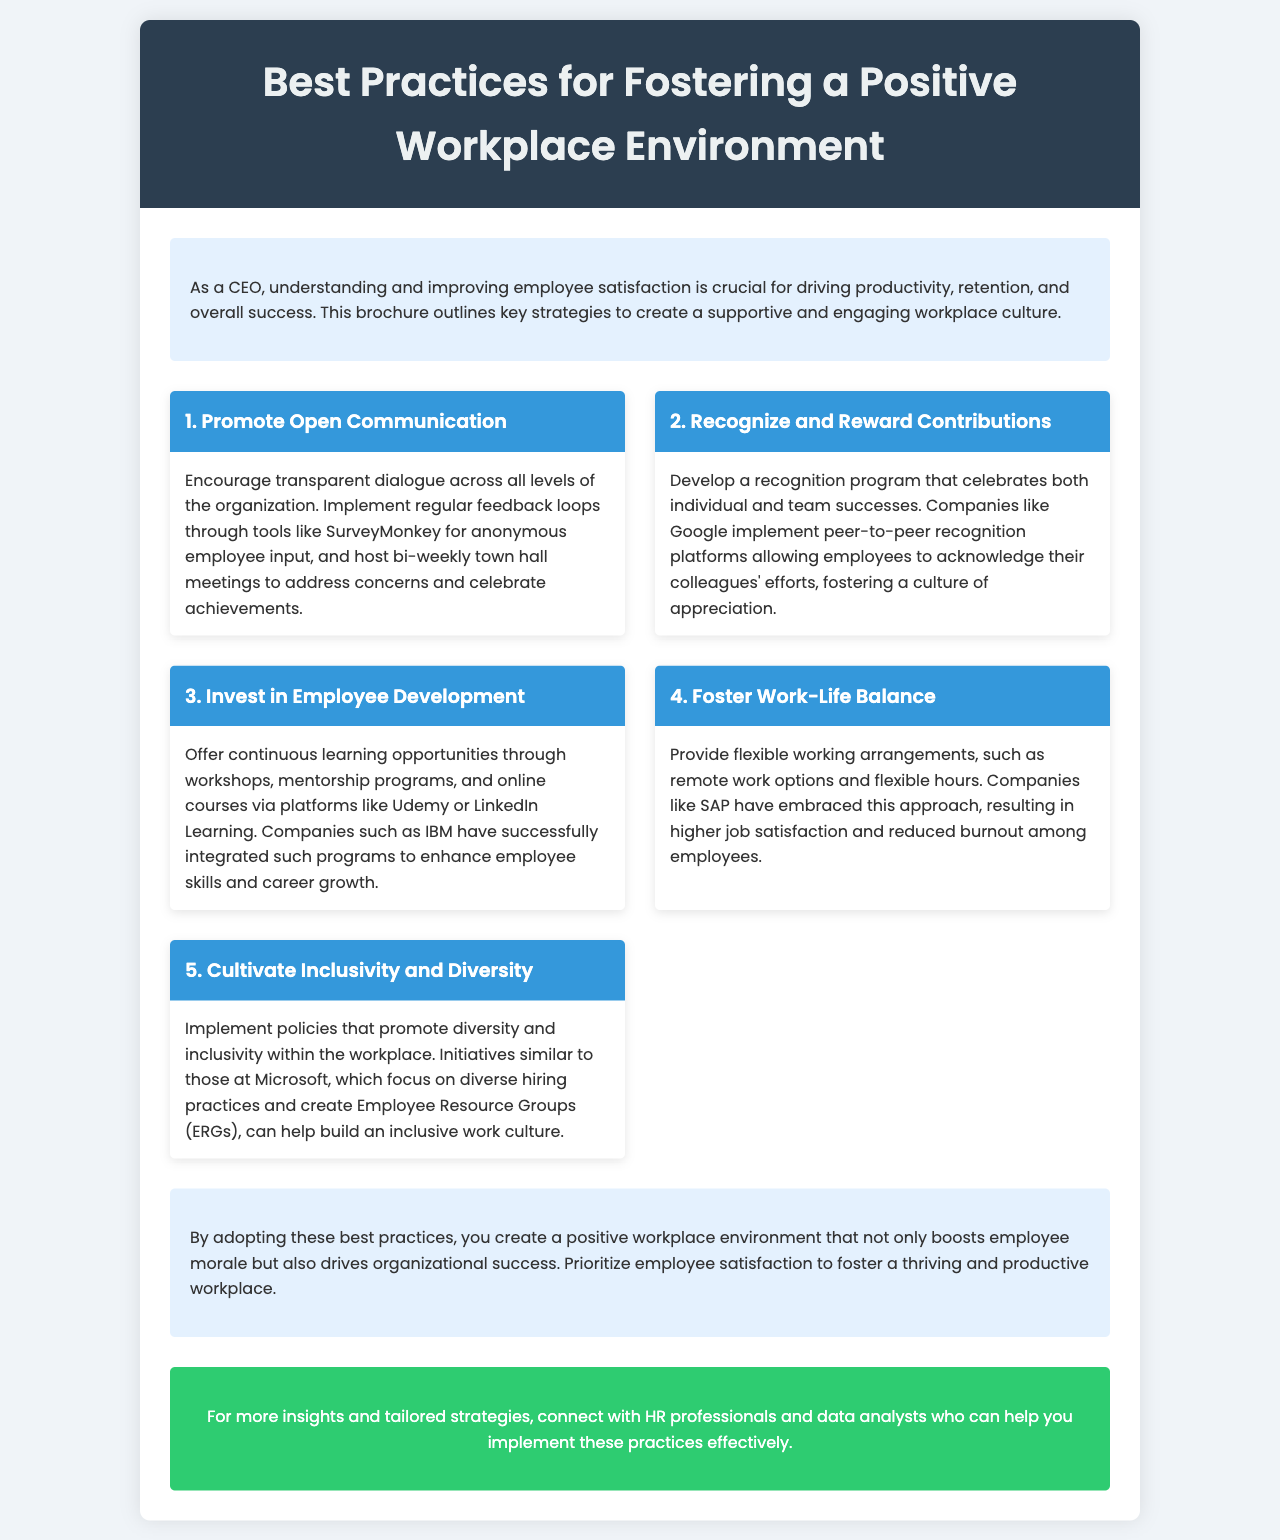What is the title of the brochure? The title is prominently displayed in the header of the document, which is "Best Practices for Fostering a Positive Workplace Environment."
Answer: Best Practices for Fostering a Positive Workplace Environment How many key practices are outlined in the brochure? The brochure lists a total of five key practices to foster a positive workplace environment.
Answer: 5 Which company is mentioned as having implemented a peer-to-peer recognition platform? The document refers to Google as a company that has an effective recognition program for employees.
Answer: Google What is the first key practice listed in the document? The first key practice is displayed as "Promote Open Communication" within the key practices section.
Answer: Promote Open Communication What does the brochure suggest regarding employee development? The brochure recommends providing continuous learning opportunities through various platforms for employee development.
Answer: Continuous learning opportunities Which company is noted for embracing flexible work arrangements? SAP is identified as a company that provides flexible working options, contributing to higher job satisfaction.
Answer: SAP What color is used for the call-to-action section? The call-to-action section of the brochure is described as having a background color of green, specifically "#2ecc71."
Answer: Green What is the overall goal of implementing the best practices mentioned? The document states the goal is to create a positive workplace environment that boosts employee morale and drives organizational success.
Answer: Boost employee morale and drive organizational success 